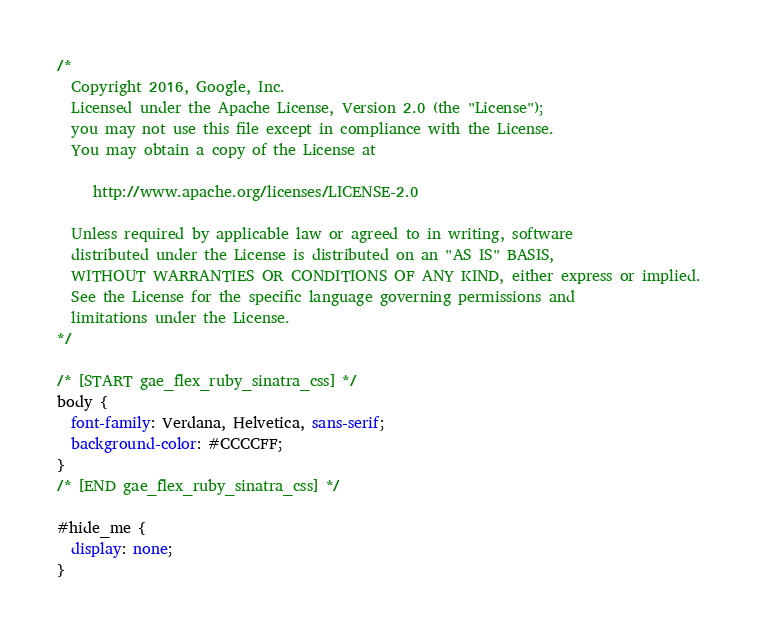<code> <loc_0><loc_0><loc_500><loc_500><_CSS_>/*
  Copyright 2016, Google, Inc.
  Licensed under the Apache License, Version 2.0 (the "License");
  you may not use this file except in compliance with the License.
  You may obtain a copy of the License at

     http://www.apache.org/licenses/LICENSE-2.0

  Unless required by applicable law or agreed to in writing, software
  distributed under the License is distributed on an "AS IS" BASIS,
  WITHOUT WARRANTIES OR CONDITIONS OF ANY KIND, either express or implied.
  See the License for the specific language governing permissions and
  limitations under the License.
*/

/* [START gae_flex_ruby_sinatra_css] */
body {
  font-family: Verdana, Helvetica, sans-serif;
  background-color: #CCCCFF;
}
/* [END gae_flex_ruby_sinatra_css] */

#hide_me {
  display: none;
}
</code> 